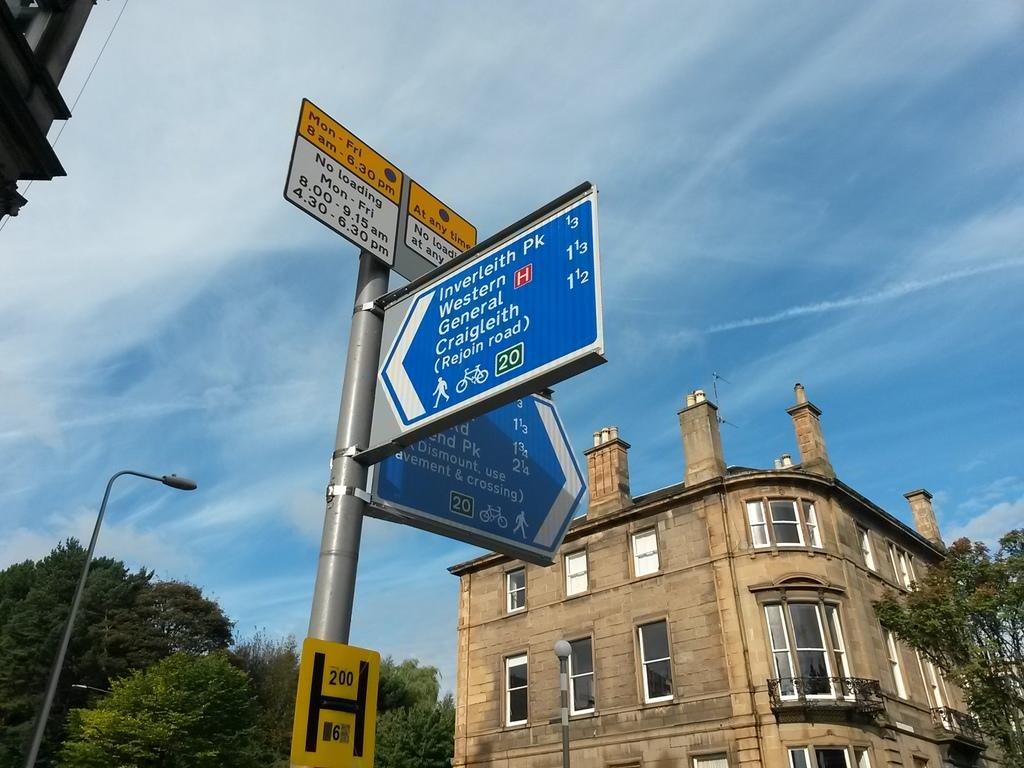What is attached to the pole in the image? There are sign boards attached to the pole in the image. What can be seen illuminating the area in the image? There are street lights in the image. What type of vegetation is present in the image? There are trees in the image. What type of structure is visible in the image? There is a building in the image. How many sinks are visible in the image? There are no sinks present in the image. What type of knowledge can be gained from the sign boards in the image? The sign boards in the image may provide information or directions, but they do not convey knowledge in the sense of an academic subject. 